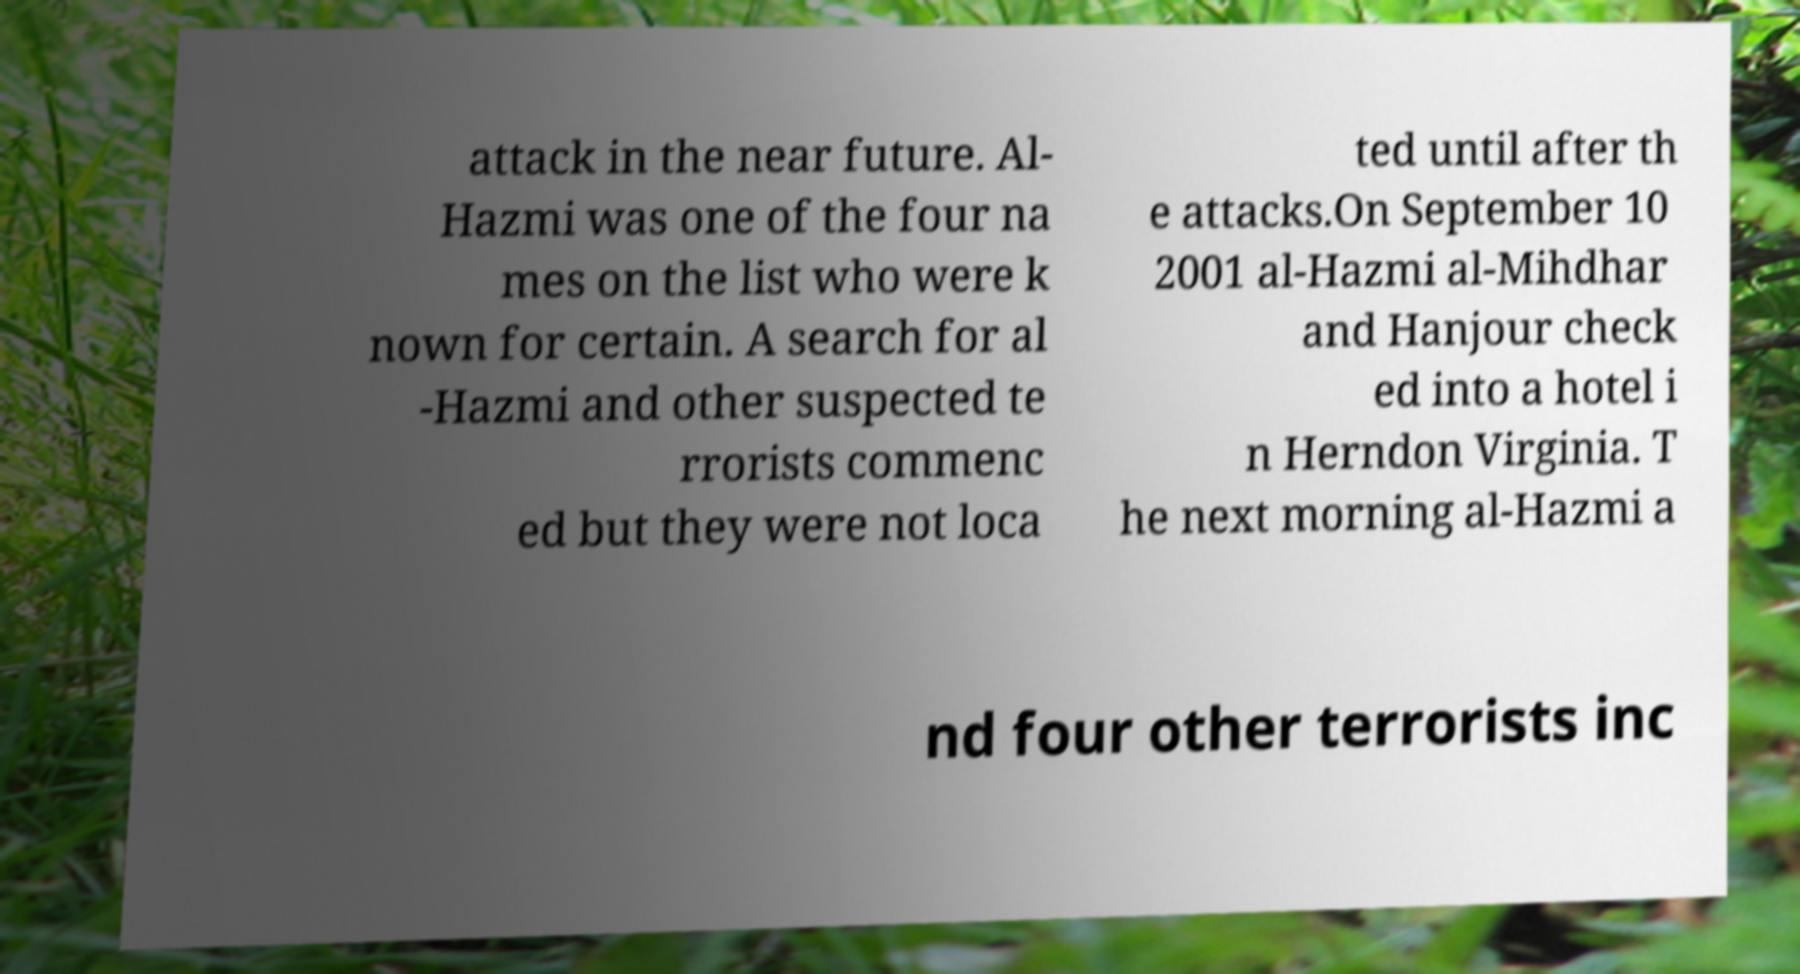Could you extract and type out the text from this image? attack in the near future. Al- Hazmi was one of the four na mes on the list who were k nown for certain. A search for al -Hazmi and other suspected te rrorists commenc ed but they were not loca ted until after th e attacks.On September 10 2001 al-Hazmi al-Mihdhar and Hanjour check ed into a hotel i n Herndon Virginia. T he next morning al-Hazmi a nd four other terrorists inc 